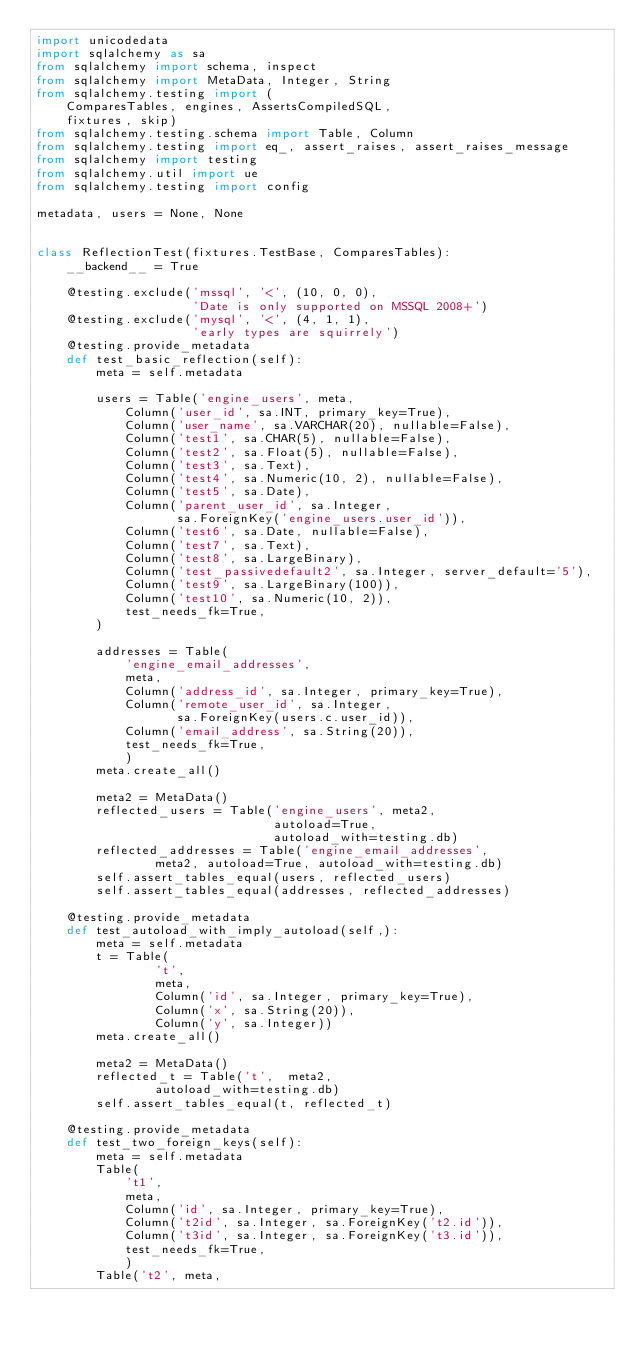Convert code to text. <code><loc_0><loc_0><loc_500><loc_500><_Python_>import unicodedata
import sqlalchemy as sa
from sqlalchemy import schema, inspect
from sqlalchemy import MetaData, Integer, String
from sqlalchemy.testing import (
    ComparesTables, engines, AssertsCompiledSQL,
    fixtures, skip)
from sqlalchemy.testing.schema import Table, Column
from sqlalchemy.testing import eq_, assert_raises, assert_raises_message
from sqlalchemy import testing
from sqlalchemy.util import ue
from sqlalchemy.testing import config

metadata, users = None, None


class ReflectionTest(fixtures.TestBase, ComparesTables):
    __backend__ = True

    @testing.exclude('mssql', '<', (10, 0, 0),
                     'Date is only supported on MSSQL 2008+')
    @testing.exclude('mysql', '<', (4, 1, 1),
                     'early types are squirrely')
    @testing.provide_metadata
    def test_basic_reflection(self):
        meta = self.metadata

        users = Table('engine_users', meta,
            Column('user_id', sa.INT, primary_key=True),
            Column('user_name', sa.VARCHAR(20), nullable=False),
            Column('test1', sa.CHAR(5), nullable=False),
            Column('test2', sa.Float(5), nullable=False),
            Column('test3', sa.Text),
            Column('test4', sa.Numeric(10, 2), nullable=False),
            Column('test5', sa.Date),
            Column('parent_user_id', sa.Integer,
                   sa.ForeignKey('engine_users.user_id')),
            Column('test6', sa.Date, nullable=False),
            Column('test7', sa.Text),
            Column('test8', sa.LargeBinary),
            Column('test_passivedefault2', sa.Integer, server_default='5'),
            Column('test9', sa.LargeBinary(100)),
            Column('test10', sa.Numeric(10, 2)),
            test_needs_fk=True,
        )

        addresses = Table(
            'engine_email_addresses',
            meta,
            Column('address_id', sa.Integer, primary_key=True),
            Column('remote_user_id', sa.Integer,
                   sa.ForeignKey(users.c.user_id)),
            Column('email_address', sa.String(20)),
            test_needs_fk=True,
            )
        meta.create_all()

        meta2 = MetaData()
        reflected_users = Table('engine_users', meta2,
                                autoload=True,
                                autoload_with=testing.db)
        reflected_addresses = Table('engine_email_addresses',
                meta2, autoload=True, autoload_with=testing.db)
        self.assert_tables_equal(users, reflected_users)
        self.assert_tables_equal(addresses, reflected_addresses)

    @testing.provide_metadata
    def test_autoload_with_imply_autoload(self,):
        meta = self.metadata
        t = Table(
                't',
                meta,
                Column('id', sa.Integer, primary_key=True),
                Column('x', sa.String(20)),
                Column('y', sa.Integer))
        meta.create_all()

        meta2 = MetaData()
        reflected_t = Table('t',  meta2,
                autoload_with=testing.db)
        self.assert_tables_equal(t, reflected_t)

    @testing.provide_metadata
    def test_two_foreign_keys(self):
        meta = self.metadata
        Table(
            't1',
            meta,
            Column('id', sa.Integer, primary_key=True),
            Column('t2id', sa.Integer, sa.ForeignKey('t2.id')),
            Column('t3id', sa.Integer, sa.ForeignKey('t3.id')),
            test_needs_fk=True,
            )
        Table('t2', meta,</code> 